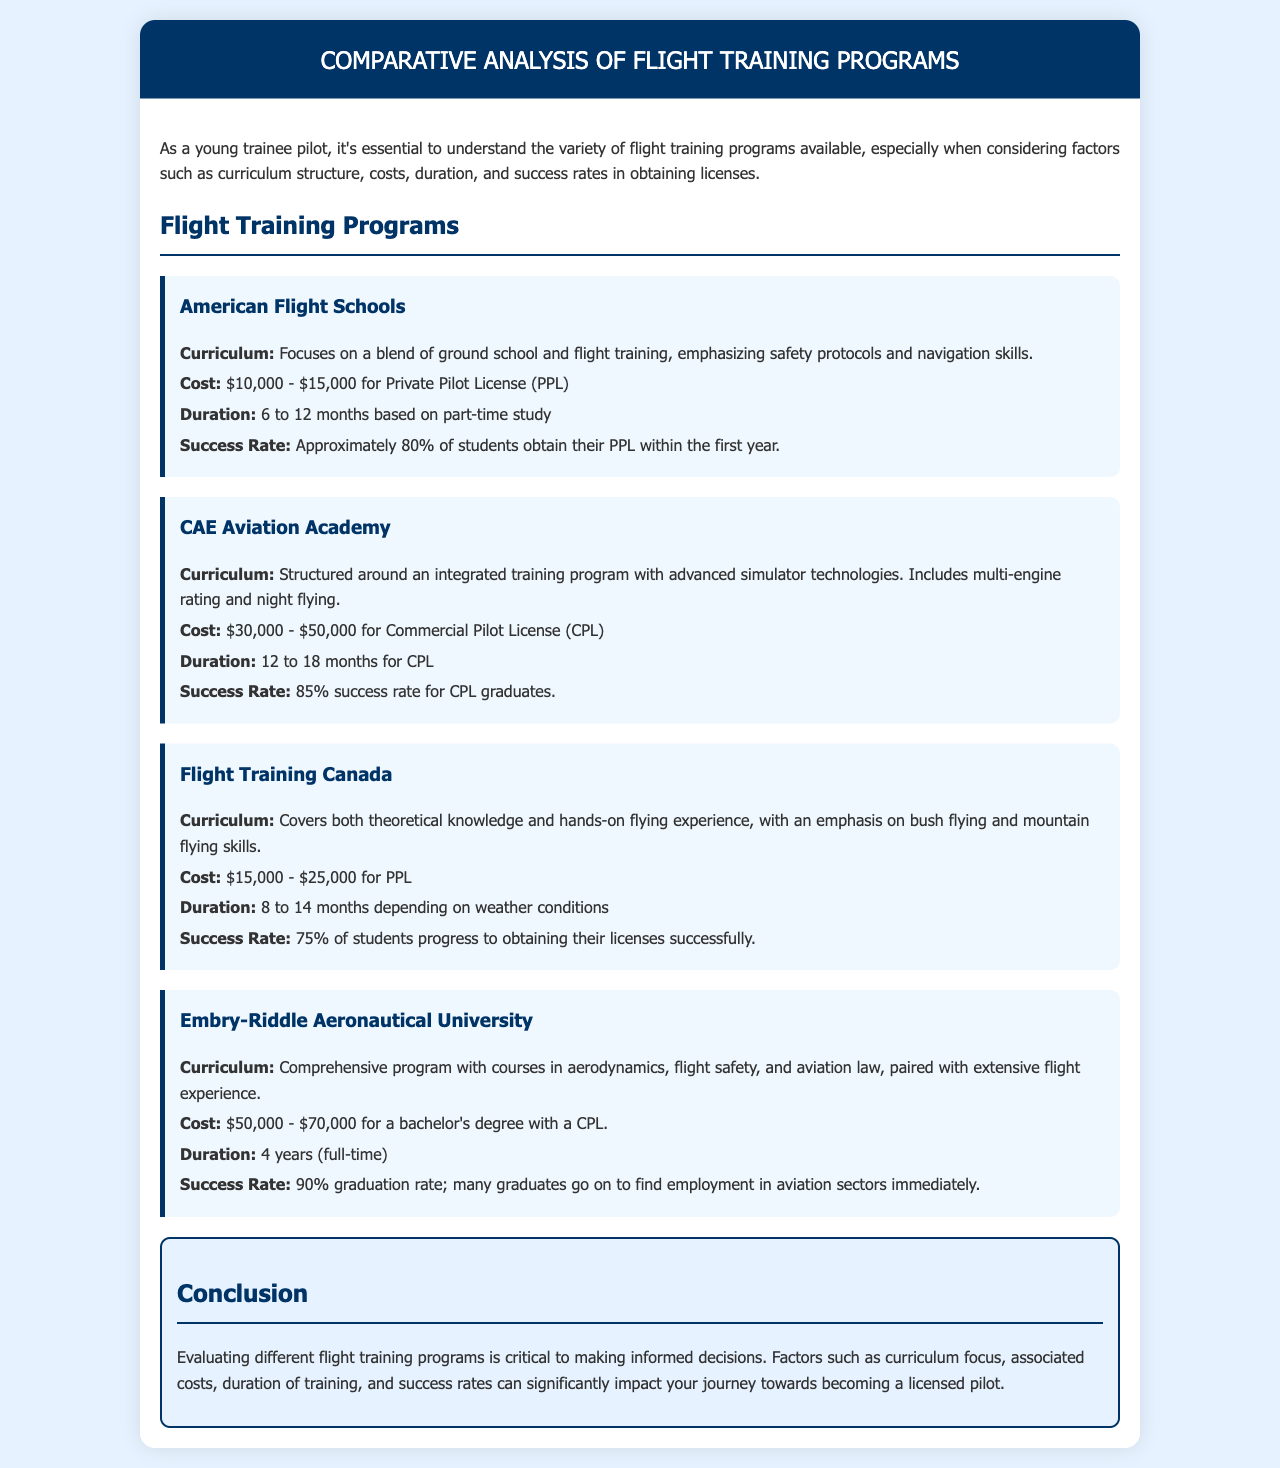What is the cost range for the American Flight Schools? The document states that the cost for the American Flight Schools ranges from $10,000 to $15,000 for a Private Pilot License.
Answer: $10,000 - $15,000 What is the success rate for CAE Aviation Academy graduates? According to the document, the success rate for CAE Aviation Academy graduates obtaining their Commercial Pilot License is 85%.
Answer: 85% What is the duration of training at Flight Training Canada? The document mentions that the duration of training at Flight Training Canada depends on weather conditions and ranges from 8 to 14 months.
Answer: 8 to 14 months Which program has the highest success rate? The document outlines that Embry-Riddle Aeronautical University has the highest success rate at 90%.
Answer: 90% How long does it take to earn a degree with a CPL at Embry-Riddle? The document specifies that it takes 4 years (full-time) to earn a bachelor's degree with a Commercial Pilot License at Embry-Riddle.
Answer: 4 years What is emphasized in the curriculum of Flight Training Canada? The curriculum of Flight Training Canada emphasizes bush flying and mountain flying skills.
Answer: bush flying and mountain flying skills Which program is structured around advanced simulator technologies? The document indicates that CAE Aviation Academy is structured around an integrated training program with advanced simulator technologies.
Answer: CAE Aviation Academy What is the cost range for a Private Pilot License at Flight Training Canada? The document states that the cost for a Private Pilot License at Flight Training Canada ranges from $15,000 to $25,000.
Answer: $15,000 - $25,000 